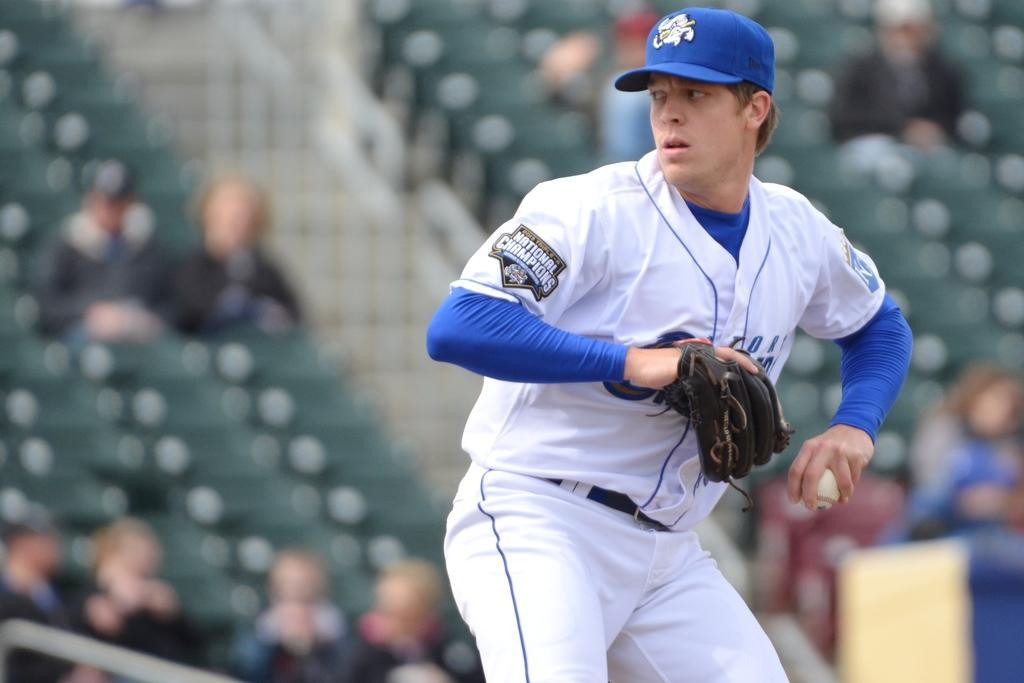How would you summarize this image in a sentence or two? In this image we can see a man. He wore a cap and a glove. There is a blur background and we can see people. 